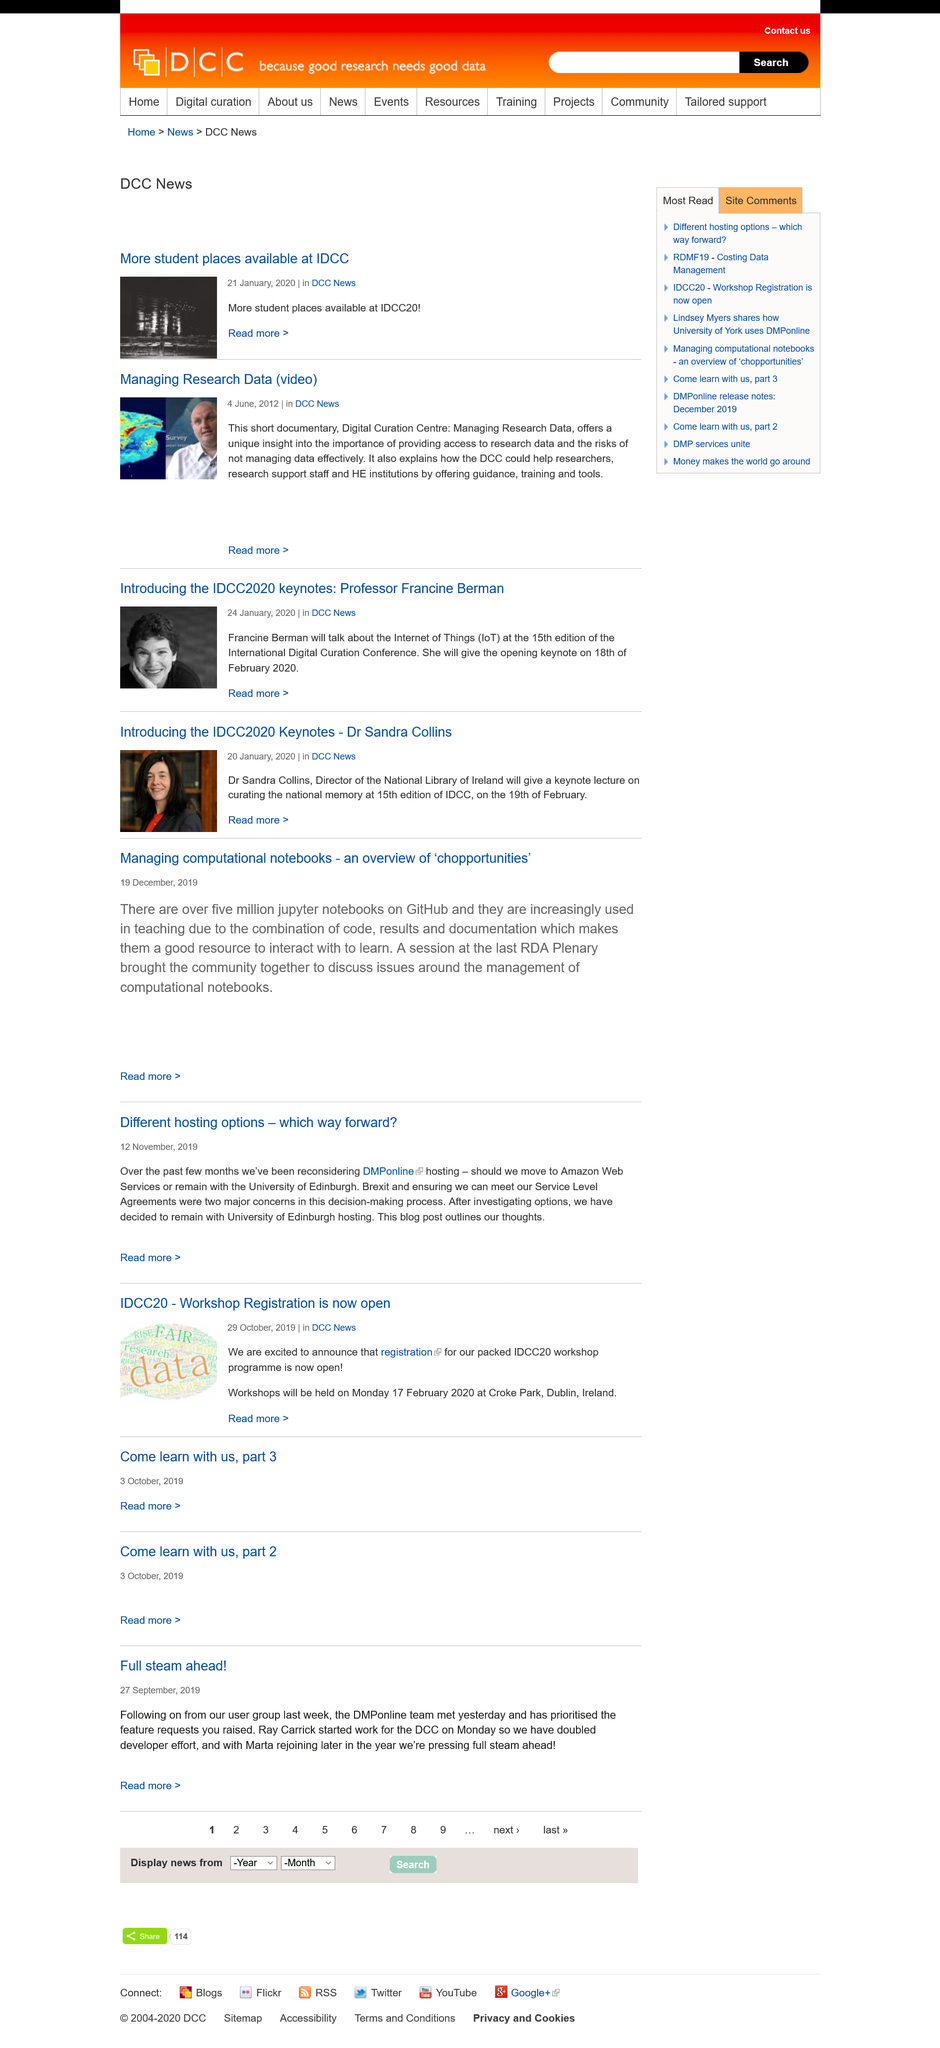Give some essential details in this illustration. There are over 5 million Jupyter notebooks available on GitHub. During the decision-making process outlined in the article "Different hosting options - which way forward?," the two primary concerns were the potential impact of Brexit on our operations and ensuring that we could maintain our Service Level Agreements. The article titled "Different hosting options-which way forward?" was published on November 12, 2018. 